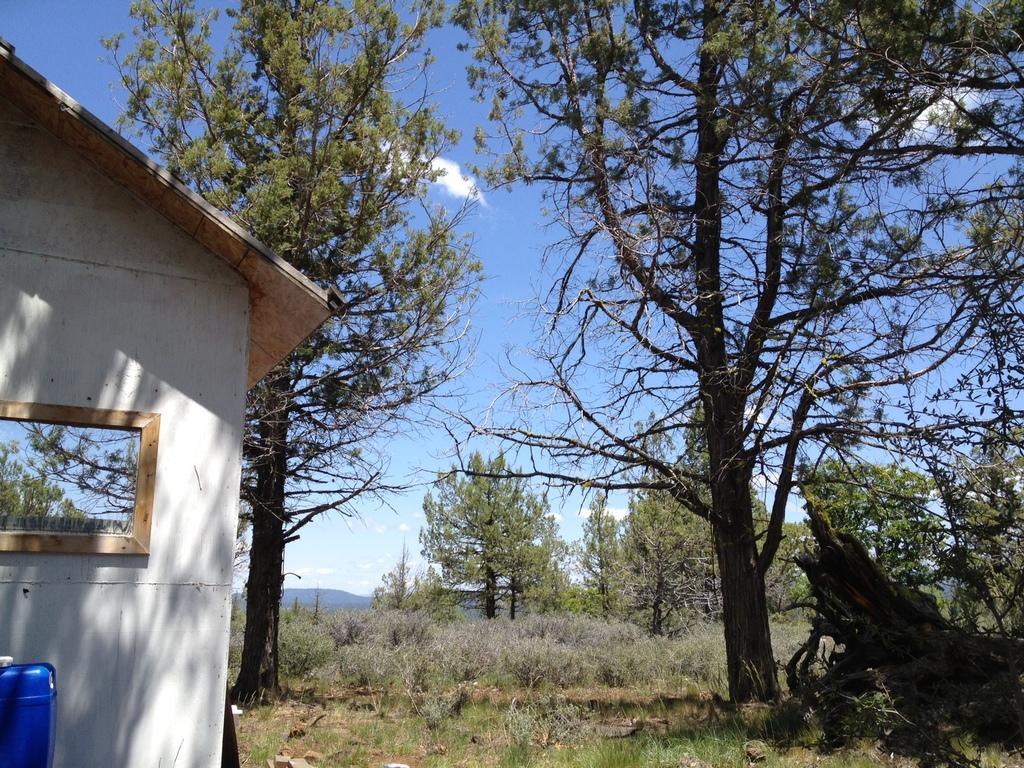How would you summarize this image in a sentence or two? In this picture we can see a house, mirror, trees, grass and in the background we can see the sky with clouds. 